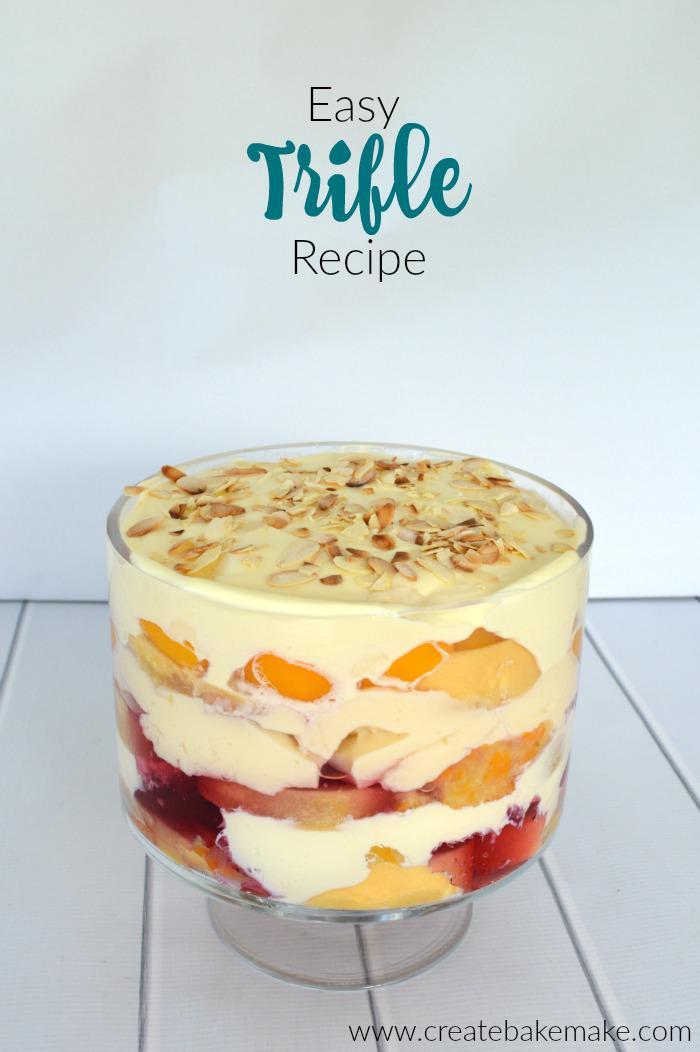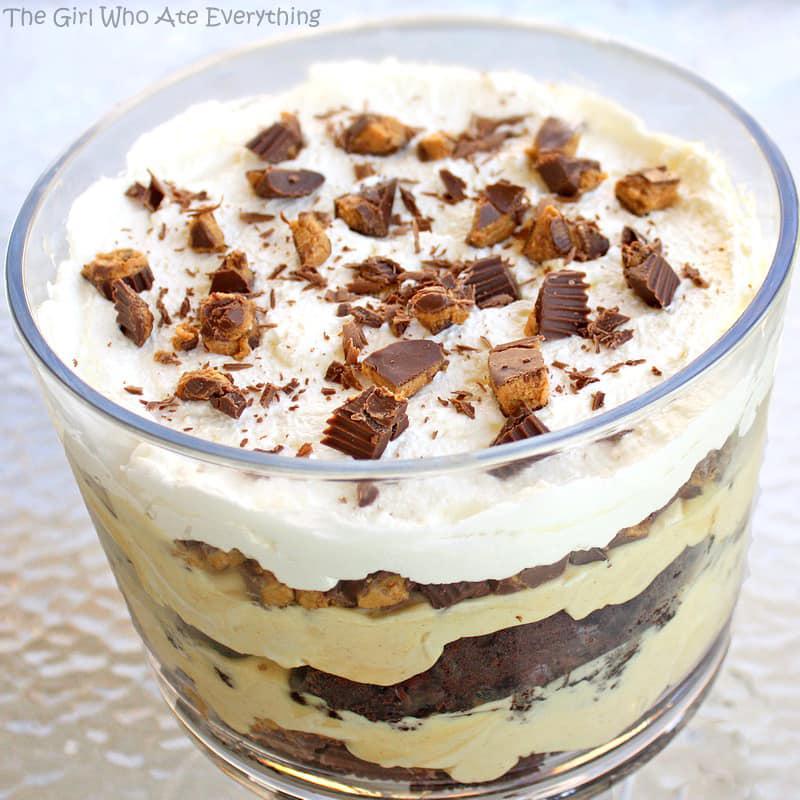The first image is the image on the left, the second image is the image on the right. For the images shown, is this caption "An image shows a layered dessert in a footed glass, with a topping that includes sliced strawberries." true? Answer yes or no. No. The first image is the image on the left, the second image is the image on the right. For the images shown, is this caption "The fancy dessert in one image is garnished with chocolate, while the other image shows dessert garnished with sliced fruit." true? Answer yes or no. No. 